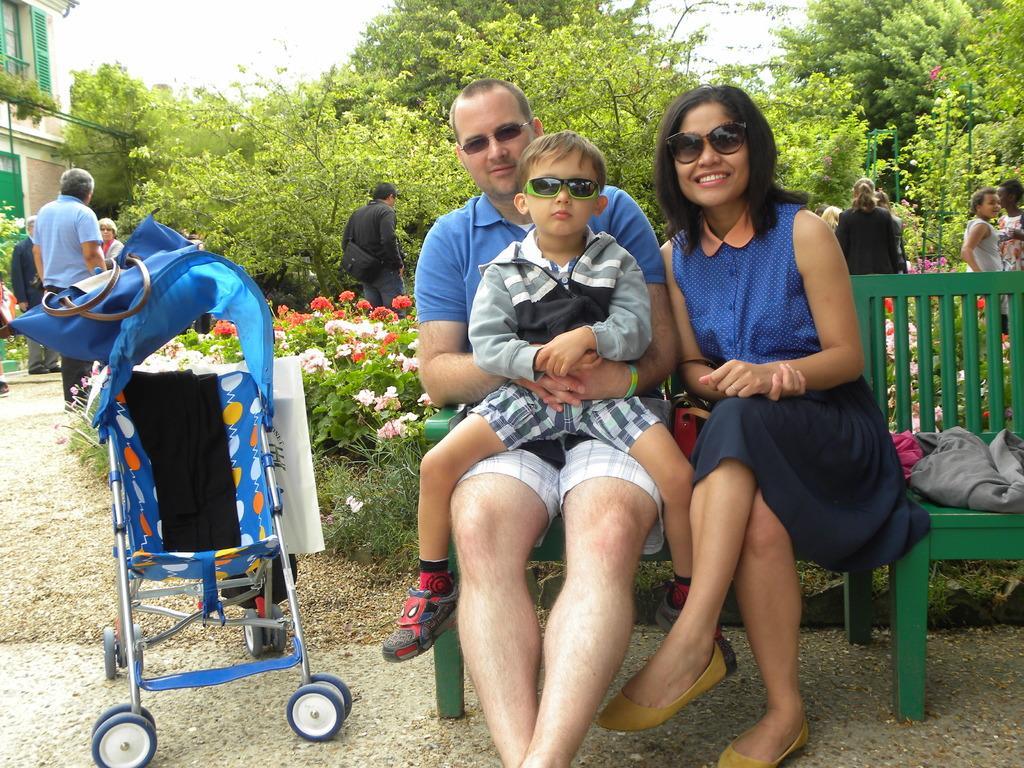How would you summarize this image in a sentence or two? In this image, we can see a few people. We can see the ground. We can see some plants with flowers. There are a few trees. We can see a baby trolley. We can see some poles. We can see a house on the left. We can see the sky. We can see the bench. 